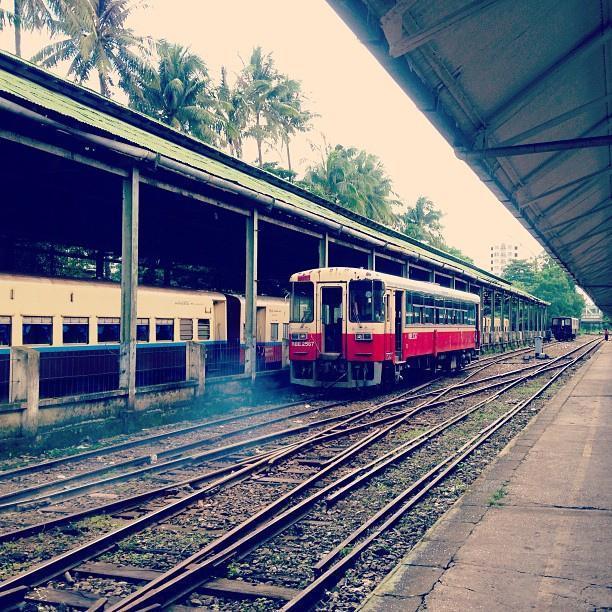How many sets of track are there?
Give a very brief answer. 4. How many trains are there?
Give a very brief answer. 2. 